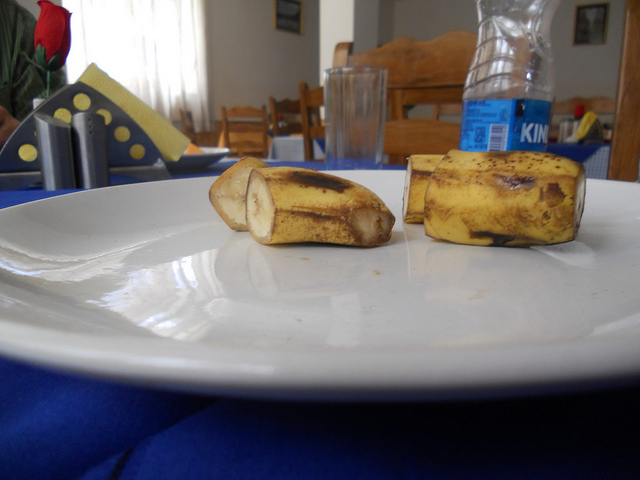Identify the text displayed in this image. KIN 